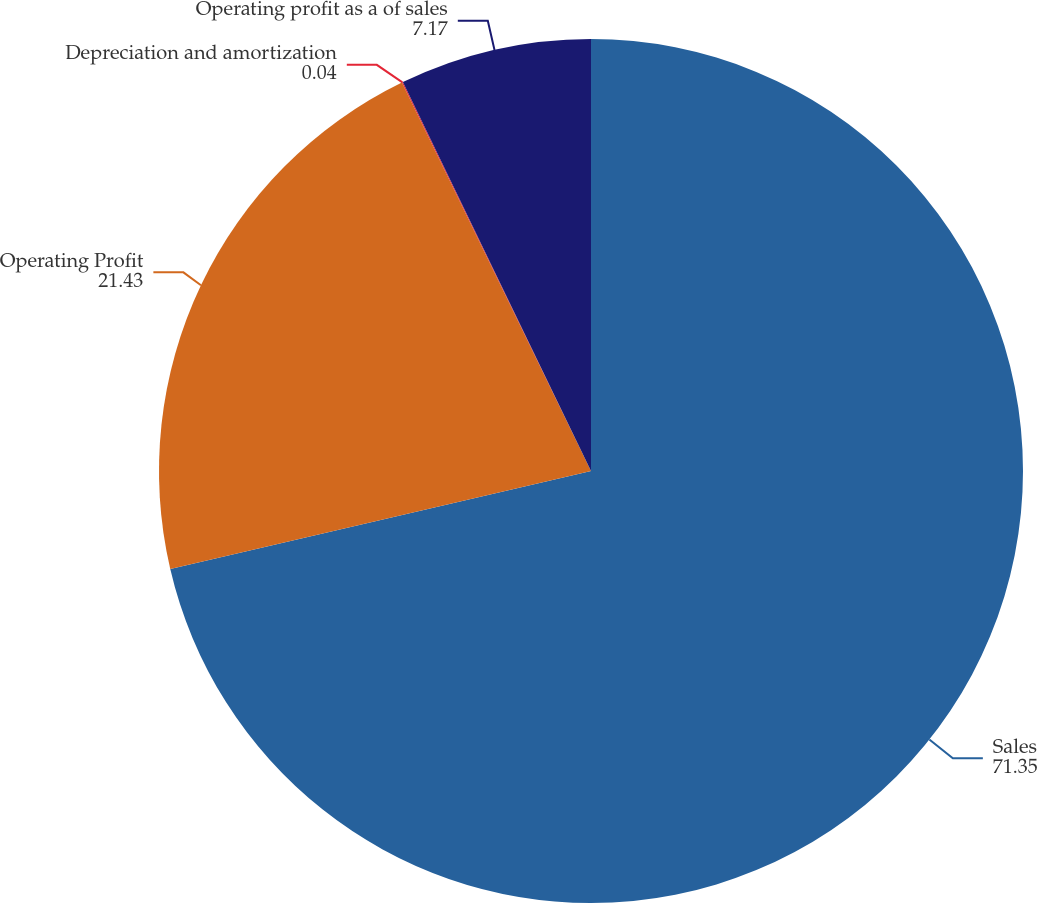Convert chart. <chart><loc_0><loc_0><loc_500><loc_500><pie_chart><fcel>Sales<fcel>Operating Profit<fcel>Depreciation and amortization<fcel>Operating profit as a of sales<nl><fcel>71.35%<fcel>21.43%<fcel>0.04%<fcel>7.17%<nl></chart> 